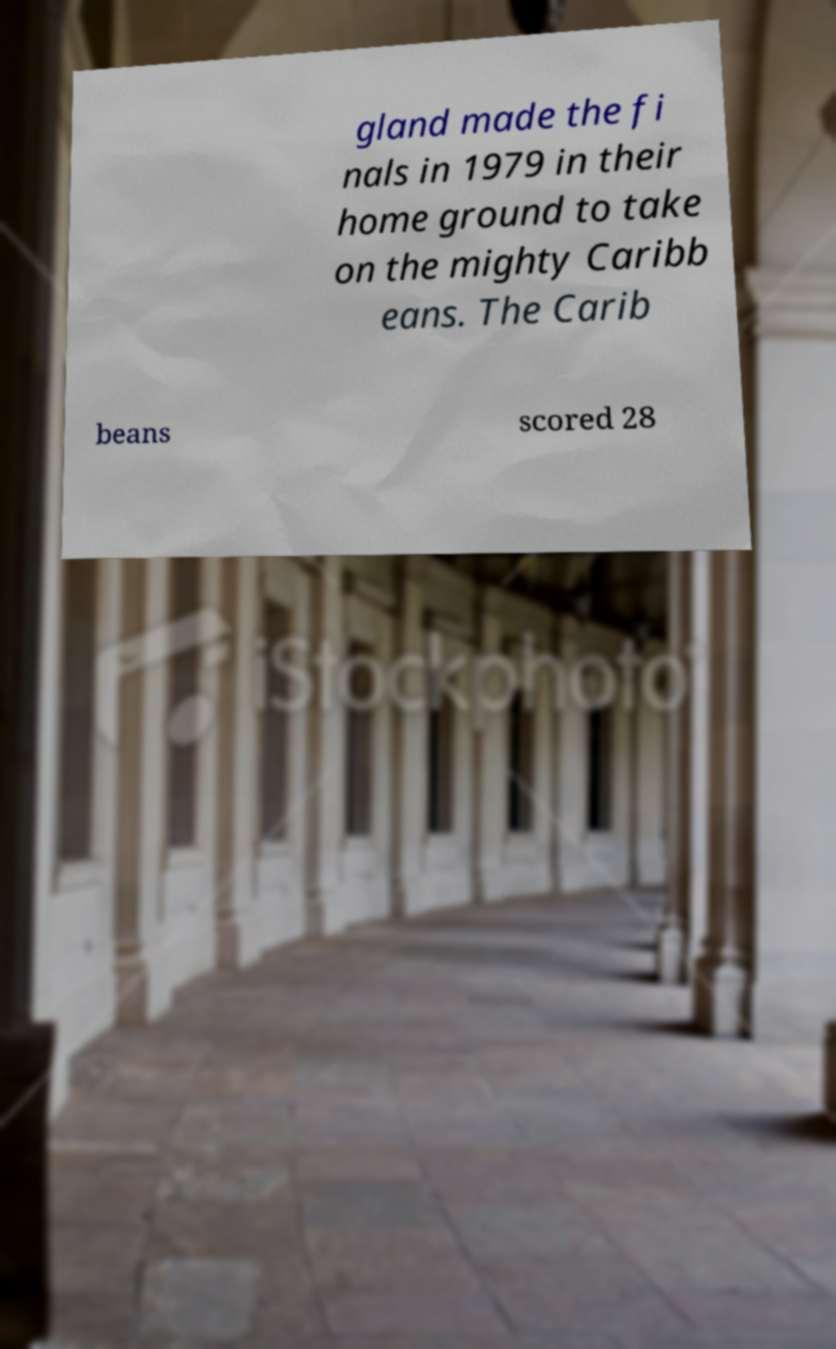Can you read and provide the text displayed in the image?This photo seems to have some interesting text. Can you extract and type it out for me? gland made the fi nals in 1979 in their home ground to take on the mighty Caribb eans. The Carib beans scored 28 